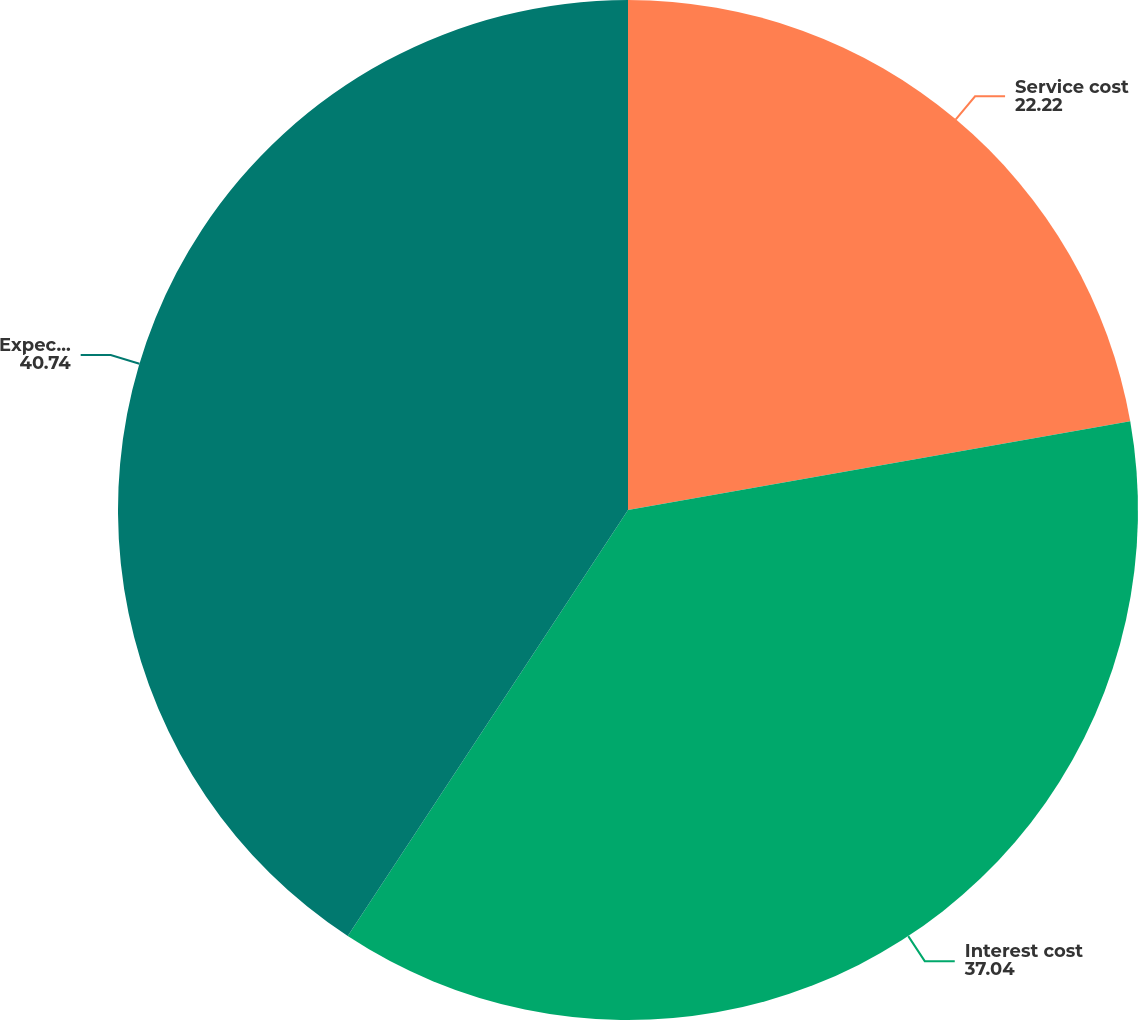Convert chart. <chart><loc_0><loc_0><loc_500><loc_500><pie_chart><fcel>Service cost<fcel>Interest cost<fcel>Expected return on plan assets<nl><fcel>22.22%<fcel>37.04%<fcel>40.74%<nl></chart> 